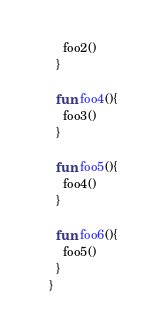<code> <loc_0><loc_0><loc_500><loc_500><_Kotlin_>    foo2()
  }

  fun foo4(){
    foo3()
  }

  fun foo5(){
    foo4()
  }

  fun foo6(){
    foo5()
  }
}</code> 